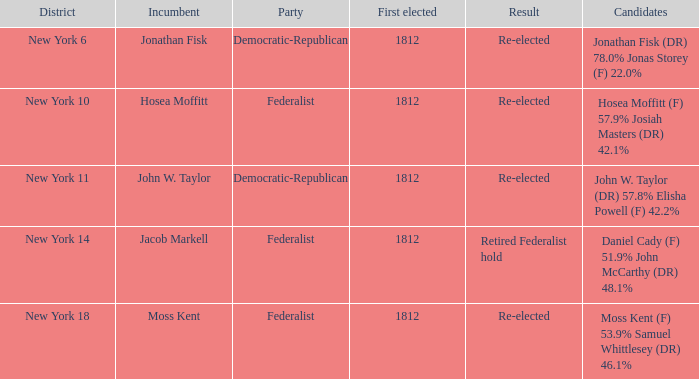Who is the present holder for new york's 10th district? Hosea Moffitt. 